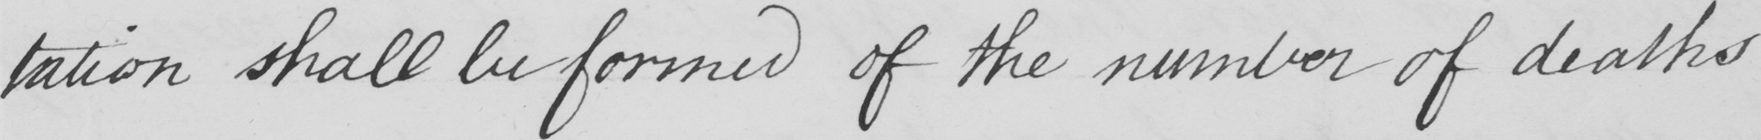Please transcribe the handwritten text in this image. -tation shall be formed of the number of deaths 